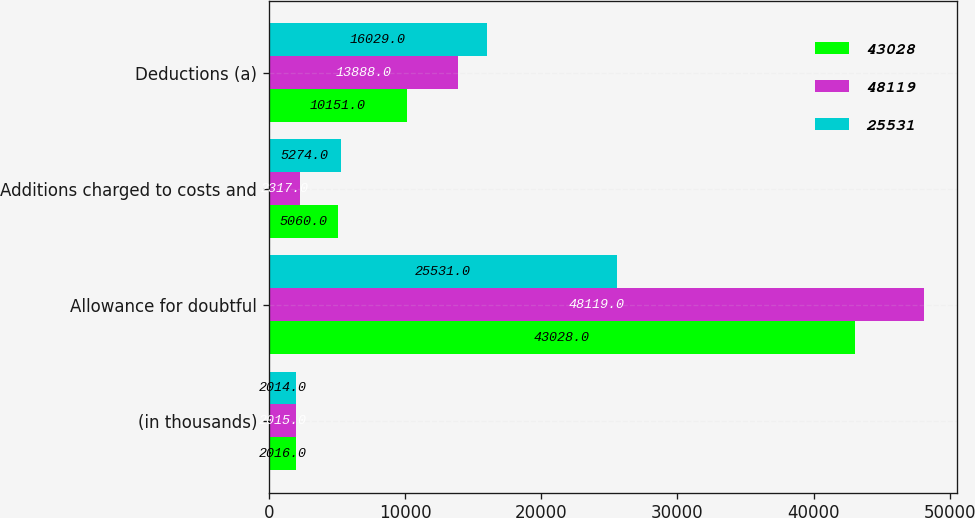Convert chart. <chart><loc_0><loc_0><loc_500><loc_500><stacked_bar_chart><ecel><fcel>(in thousands)<fcel>Allowance for doubtful<fcel>Additions charged to costs and<fcel>Deductions (a)<nl><fcel>43028<fcel>2016<fcel>43028<fcel>5060<fcel>10151<nl><fcel>48119<fcel>2015<fcel>48119<fcel>2317<fcel>13888<nl><fcel>25531<fcel>2014<fcel>25531<fcel>5274<fcel>16029<nl></chart> 